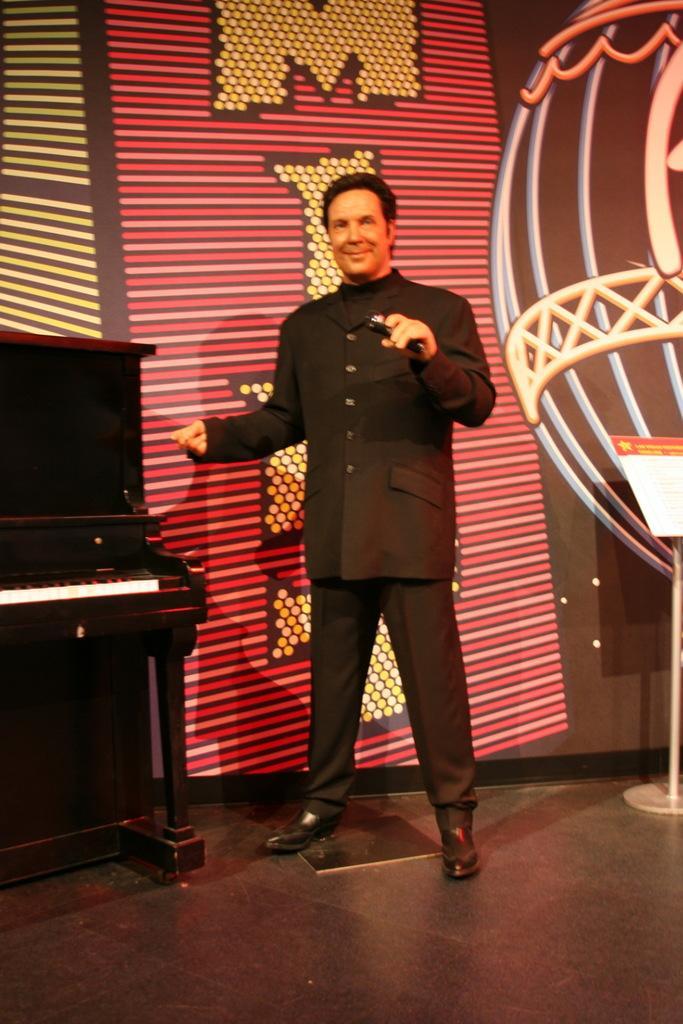In one or two sentences, can you explain what this image depicts? In this picture we can see a man standing on the floor. And this is the table, and there is a wall on the background. 